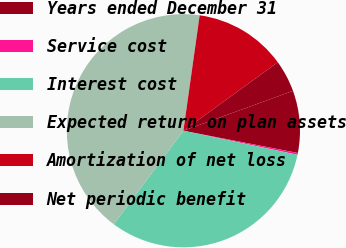<chart> <loc_0><loc_0><loc_500><loc_500><pie_chart><fcel>Years ended December 31<fcel>Service cost<fcel>Interest cost<fcel>Expected return on plan assets<fcel>Amortization of net loss<fcel>Net periodic benefit<nl><fcel>8.61%<fcel>0.25%<fcel>31.88%<fcel>42.04%<fcel>12.79%<fcel>4.43%<nl></chart> 